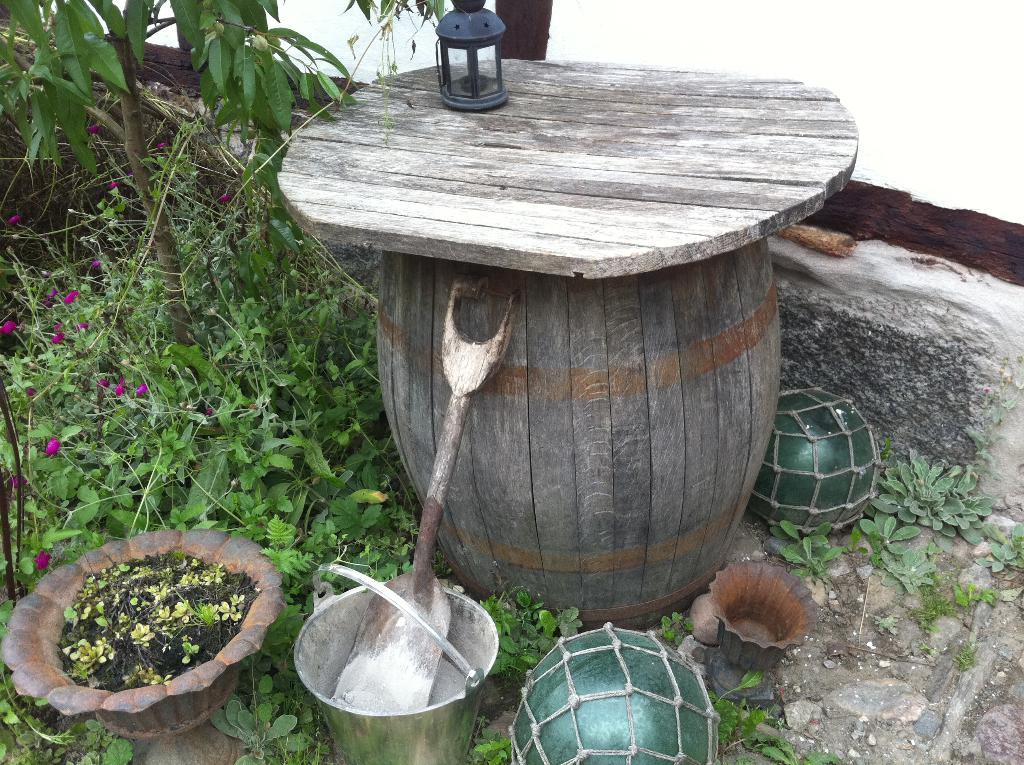What type of pot is visible in the image? There is a wooden pot in the image. What is inside the pot? The provided facts do not mention what is inside the pot. What type of plants are in the image? There are plants in the image, and they are green in color. What type of error message is displayed on the army's account in the image? There is no mention of an error message, an army, or an account in the image. The image only features a wooden pot with green plants. 